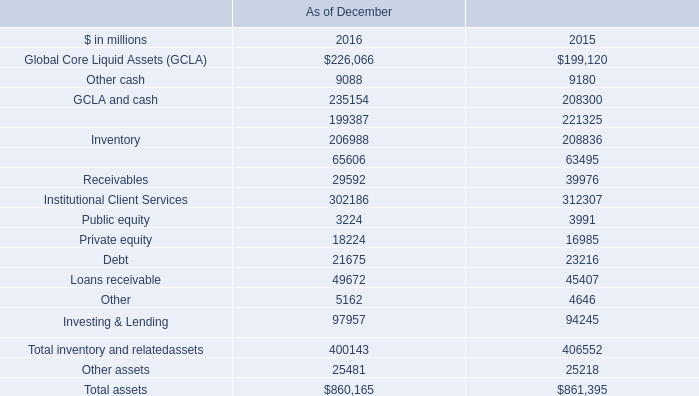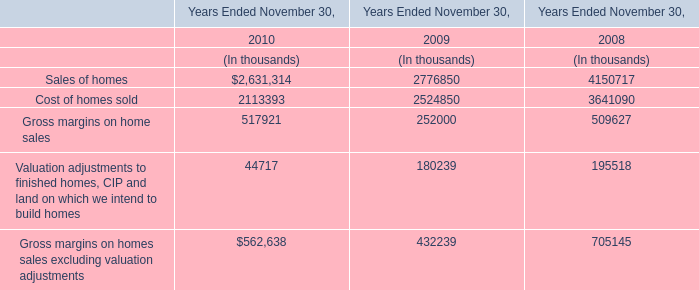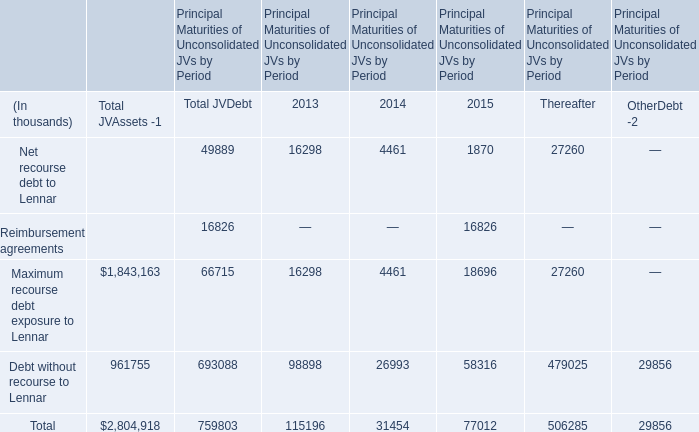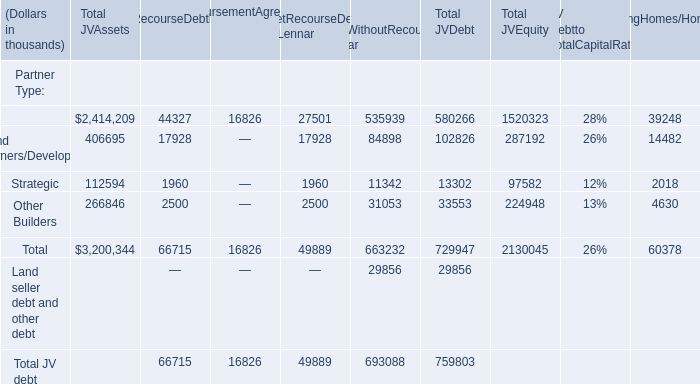Between 2013,2014 and 2015, for which year is Debt without recourse to Lennar in terms of Principal Maturities of Unconsolidated JVs by Period the least ? 
Answer: 2014. 